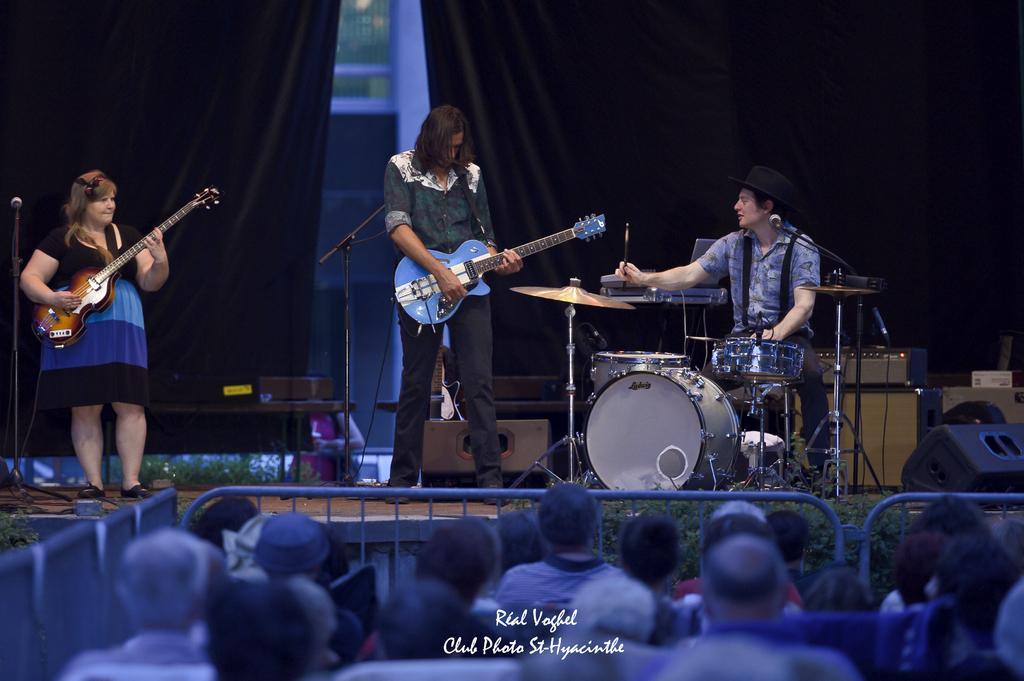In one or two sentences, can you explain what this image depicts? In the picture we can see a three people on the stage, one woman, man and other man is sitting on the chair. woman and man holding a guitars and man is sitting is playing a musical instruments. Under the stage there is a railing next to it we can see the people standing and watching them. In the background we can find a curtain which is black in colour. 